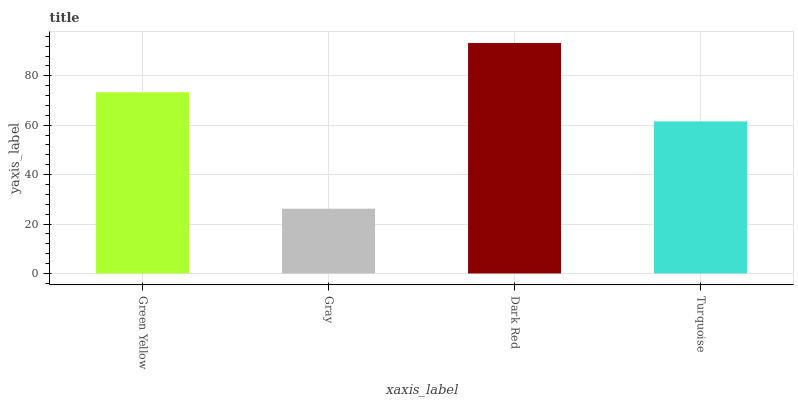Is Gray the minimum?
Answer yes or no. Yes. Is Dark Red the maximum?
Answer yes or no. Yes. Is Dark Red the minimum?
Answer yes or no. No. Is Gray the maximum?
Answer yes or no. No. Is Dark Red greater than Gray?
Answer yes or no. Yes. Is Gray less than Dark Red?
Answer yes or no. Yes. Is Gray greater than Dark Red?
Answer yes or no. No. Is Dark Red less than Gray?
Answer yes or no. No. Is Green Yellow the high median?
Answer yes or no. Yes. Is Turquoise the low median?
Answer yes or no. Yes. Is Gray the high median?
Answer yes or no. No. Is Green Yellow the low median?
Answer yes or no. No. 